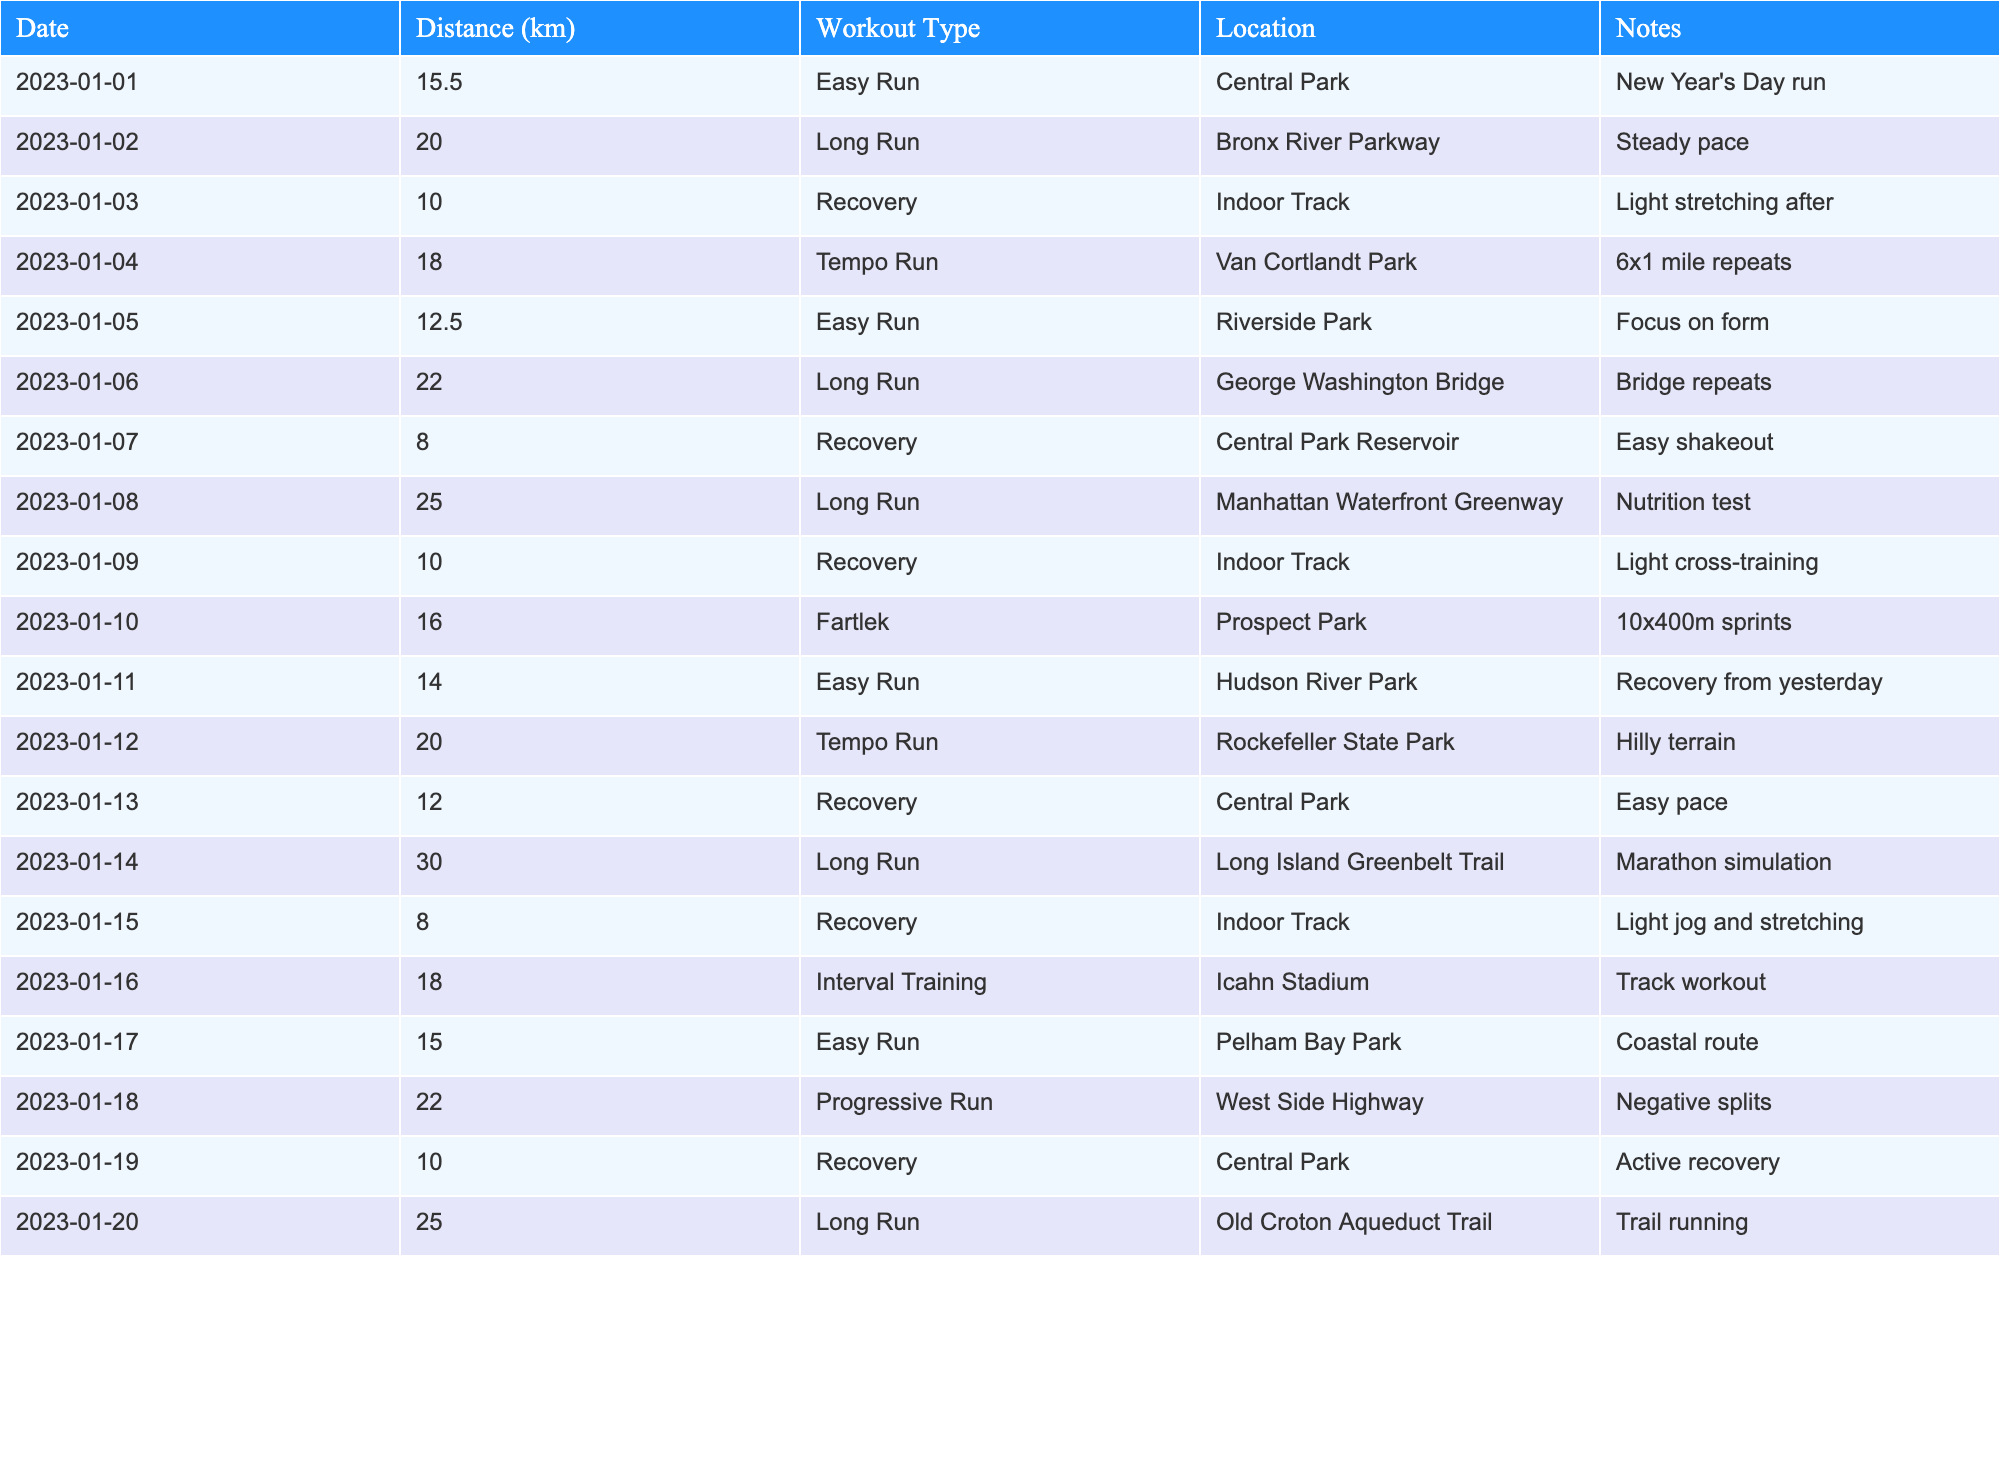What was the longest distance run in a single workout? The maximum distance value in the "Distance (km)" column is 30.
Answer: 30 km How many recovery workouts are listed? Counting the entries in the "Workout Type" column labeled as "Recovery," there are 6 instances.
Answer: 6 What was the average distance of all long runs? The distances for long runs are 20.0, 22.0, 25.0, 30.0, and 25.0. Summing these gives 122.0 km, and dividing by 5 gives an average of 24.4 km.
Answer: 24.4 km Was there a tempo run on January 12? Yes, there is a tempo run listed for January 12 in the "Workout Type" column.
Answer: Yes What is the total distance run in recovery workouts? The recovery distances are 10.0, 8.0, 10.0, 12.0, 10.0, and 10.0, which sum to 60.0 km.
Answer: 60.0 km On which date was the longest run done, and what type was it? The longest run of 30 km was done on January 14, categorized as a "Long Run."
Answer: January 14, Long Run What percentage of the workouts were easy runs? There are 4 easy runs out of 20 workouts, which gives a percentage of (4/20)*100 = 20%.
Answer: 20% How many workouts took place in Central Park? There are 5 entries where the "Location" is Central Park.
Answer: 5 What was the difference between the longest and shortest workout distances recorded? The longest run was 30.0 km and the shortest distance was 8.0 km. The difference is 30.0 - 8.0 = 22.0 km.
Answer: 22.0 km Which workout had the most distance covered in a single instance and what was the note related to it? The longest distance workout is 30 km on January 14, and the note states it was a "Marathon simulation."
Answer: Marathon simulation 